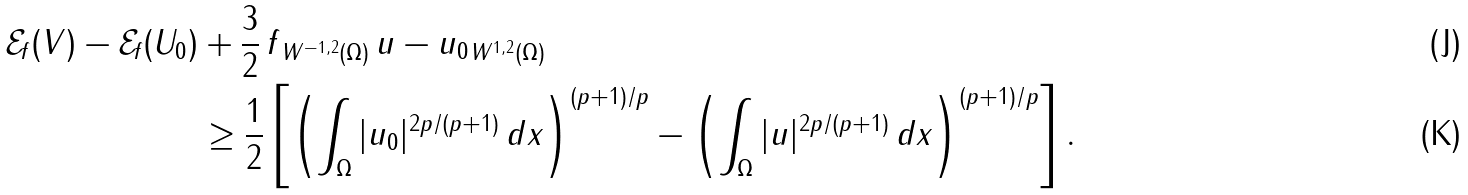Convert formula to latex. <formula><loc_0><loc_0><loc_500><loc_500>\mathcal { E } _ { f } ( V ) - \mathcal { E } _ { f } ( U _ { 0 } ) & + \frac { 3 } { 2 } \, \| f \| _ { W ^ { - 1 , 2 } ( \Omega ) } \, \| u - u _ { 0 } \| _ { W ^ { 1 , 2 } ( \Omega ) } \\ & \geq \frac { 1 } { 2 } \left [ \left ( \int _ { \Omega } | u _ { 0 } | ^ { 2 p / ( p + 1 ) } \, d x \right ) ^ { ( p + 1 ) / p } - \left ( \int _ { \Omega } | u | ^ { 2 p / ( p + 1 ) } \, d x \right ) ^ { ( p + 1 ) / p } \right ] .</formula> 